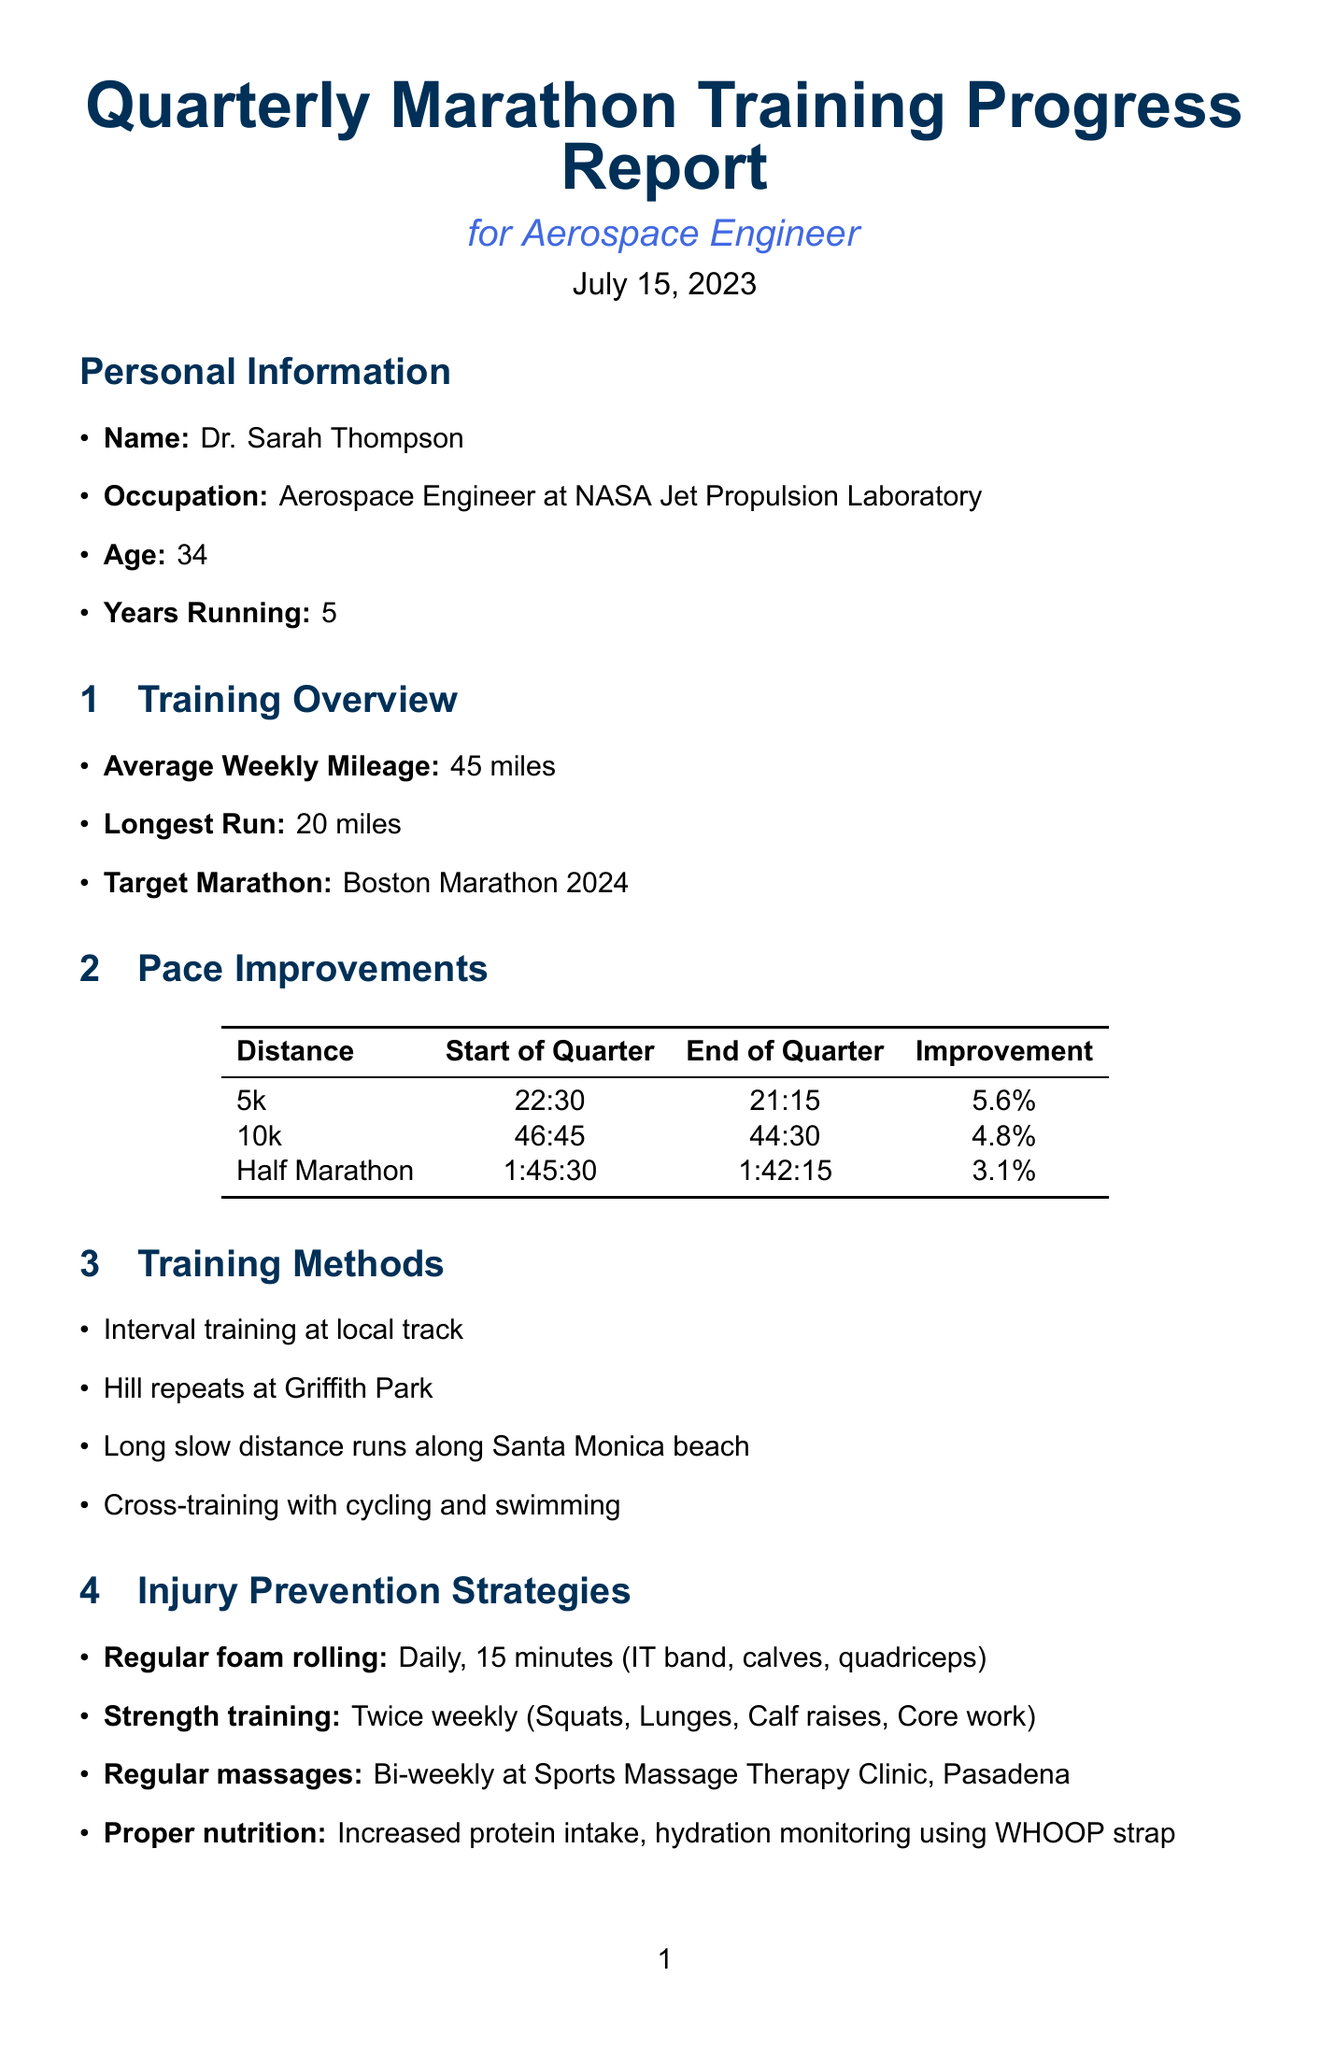What is the target marathon? The target marathon mentioned in the document is Boston Marathon 2024.
Answer: Boston Marathon 2024 How much was the improvement in the half marathon pace? The half marathon pace improved from 1:45:30 to 1:42:15, which is a decrease of 3.1%.
Answer: 3.1% What are the two strength training exercises listed? The document specifies "Squats" and "Lunges" as part of the strength training exercises.
Answer: Squats, Lunges What is the average weekly mileage? The average weekly mileage stated in the document is 45 miles.
Answer: 45 miles What notable achievement is mentioned for the 10k race? The document states that the personal best in a local 10k race is 43:20.
Answer: 43:20 What challenge is faced relating to project deadlines? The challenge mentioned involves balancing training with demanding aerospace project deadlines.
Answer: Balancing training with demanding aerospace project deadlines What is the frequency of regular massages as part of injury prevention? The document indicates that regular massages are provided bi-weekly.
Answer: Bi-weekly In what location are hill repeats conducted? Hill repeats are conducted at Griffith Park, according to the document.
Answer: Griffith Park 